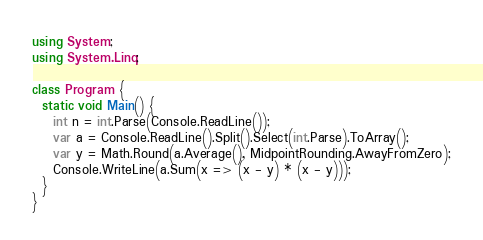<code> <loc_0><loc_0><loc_500><loc_500><_C#_>using System;
using System.Linq;

class Program {
  static void Main() {
    int n = int.Parse(Console.ReadLine());
    var a = Console.ReadLine().Split().Select(int.Parse).ToArray();
    var y = Math.Round(a.Average(), MidpointRounding.AwayFromZero);
    Console.WriteLine(a.Sum(x => (x - y) * (x - y)));
  }
}</code> 